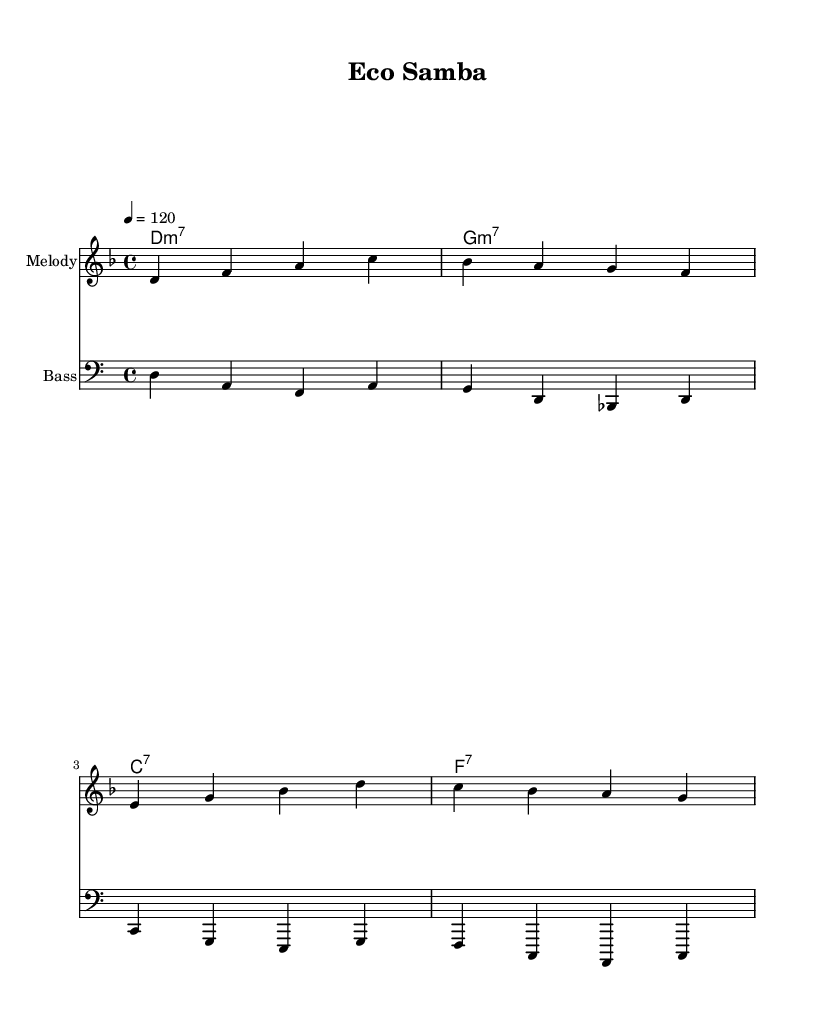What is the key signature of this music? The key signature is D minor, which has one flat (B flat). This can be identified at the beginning of the sheet music where the key signature is indicated in the notation.
Answer: D minor What is the time signature of this music? The time signature is 4/4, shown at the beginning of the sheet music. It indicates that there are four beats in each measure and a quarter note receives one beat.
Answer: 4/4 What is the tempo marking indicated in the music? The tempo marking is 120, which is notated above the staff indicating the speed at which the music should be played, specifically, 120 beats per minute.
Answer: 120 How many measures are there in the melody line? The melody line consists of four measures, which can be counted by identifying the bars that delineate each measure in the notation.
Answer: 4 What chord follows the D minor chord in the chord progression? The chord that follows the D minor chord (D minor 7) in the progression is G minor 7. This is determined by looking at the chord names written above the measures and identifying the sequence.
Answer: G minor 7 What kind of rhythm would typically be found in Latin jazz, as reflected in the melody? The rhythm typically found in Latin jazz is syncopated, emphasizing the off-beats and adding a lively character. This can be inferred from the note placements and accents that create a swing feel, common in Latin styles.
Answer: Syncopated What is the last note of the bass line? The last note of the bass line is C, as seen in the final measure and indicated by the note placement in the bass clef.
Answer: C 